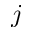Convert formula to latex. <formula><loc_0><loc_0><loc_500><loc_500>j</formula> 